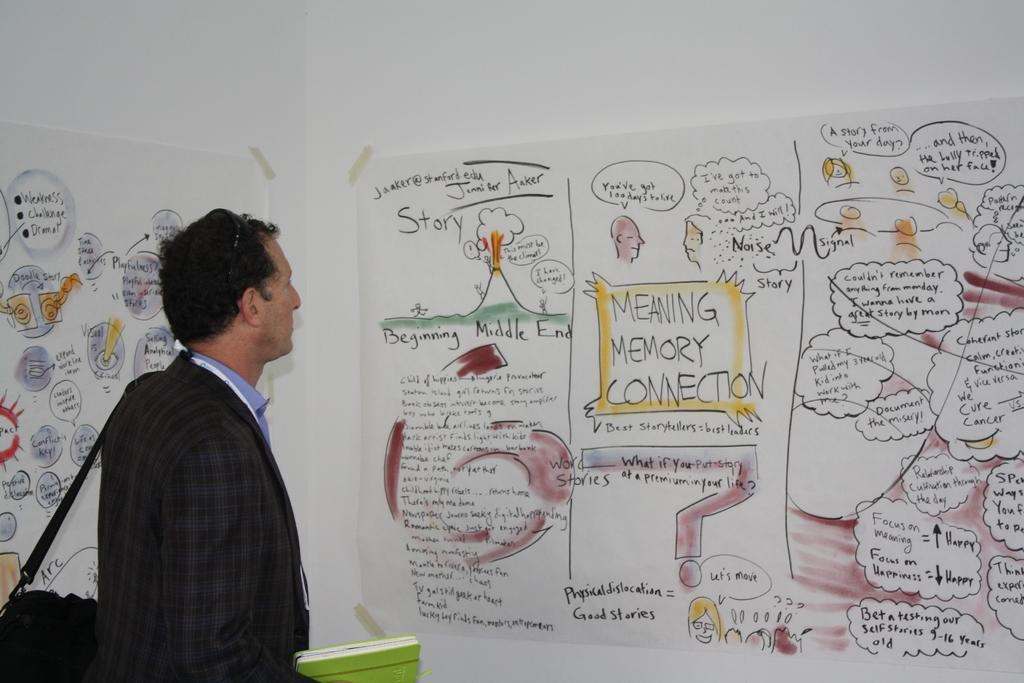Provide a one-sentence caption for the provided image. Meaning Memory Connection on a poster telling a story. 